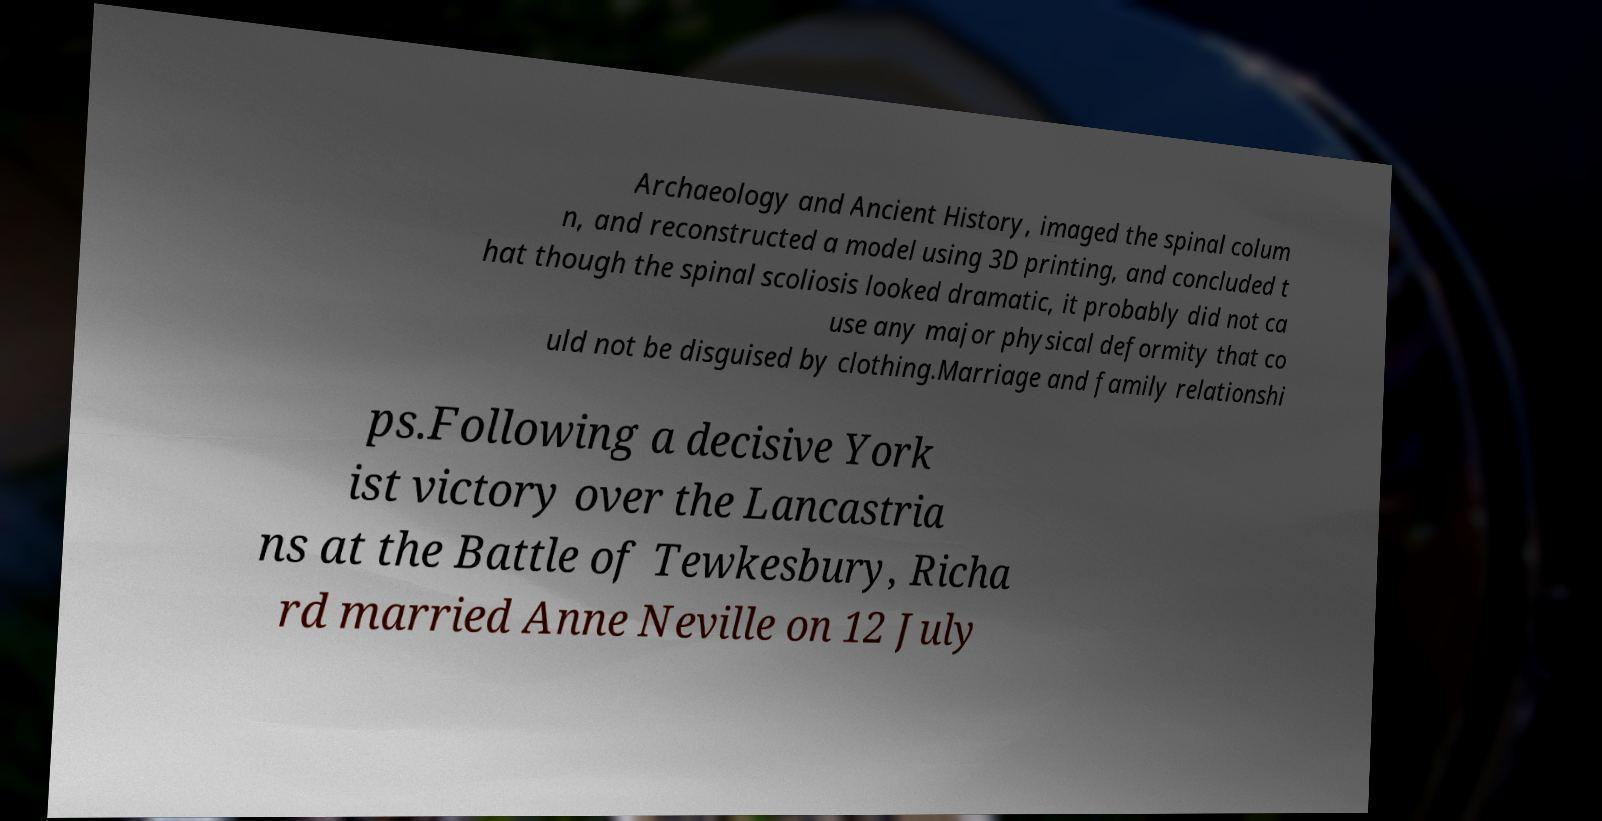Can you read and provide the text displayed in the image?This photo seems to have some interesting text. Can you extract and type it out for me? Archaeology and Ancient History, imaged the spinal colum n, and reconstructed a model using 3D printing, and concluded t hat though the spinal scoliosis looked dramatic, it probably did not ca use any major physical deformity that co uld not be disguised by clothing.Marriage and family relationshi ps.Following a decisive York ist victory over the Lancastria ns at the Battle of Tewkesbury, Richa rd married Anne Neville on 12 July 